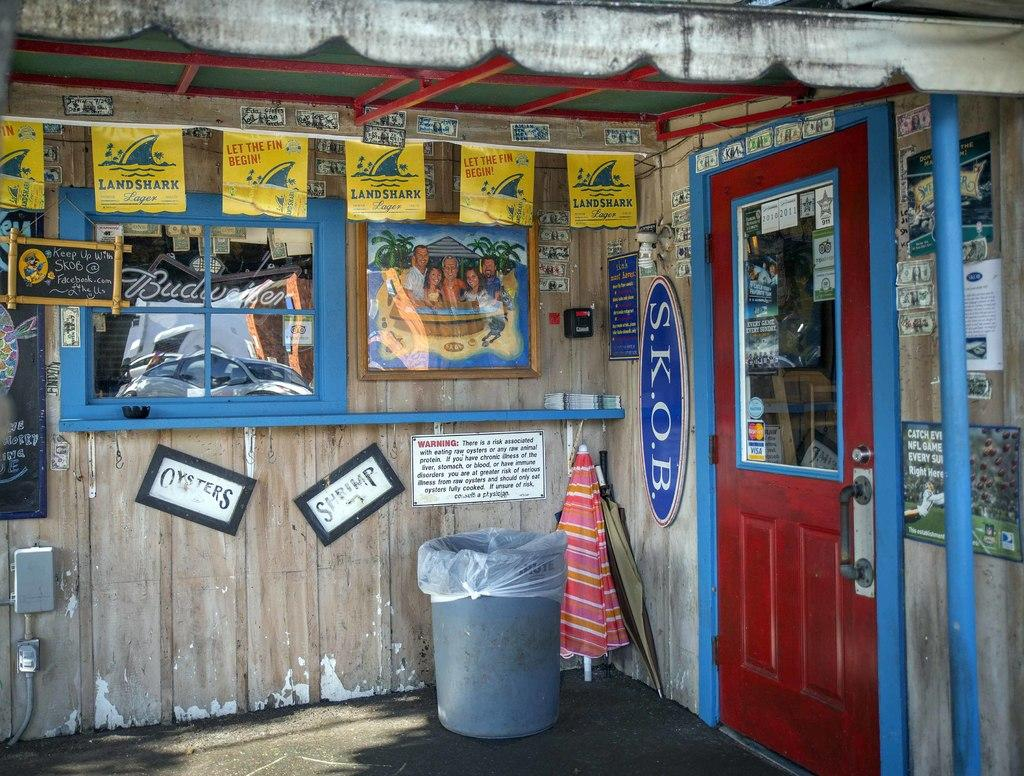What type of space is shown in the image? The image depicts a room. What can be seen on the walls of the room? There are posters on the wall in the room. How can one enter or exit the room? There is a door in the room. What is used for waste disposal in the room? There is a dustbin in the room. What type of dog is sitting next to the governor in the image? There is no governor or dog present in the image; it only shows a room with posters, a door, and a dustbin. 